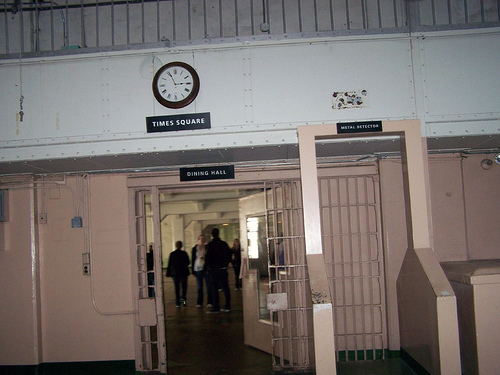<image>
Is the man in the doorway? No. The man is not contained within the doorway. These objects have a different spatial relationship. 